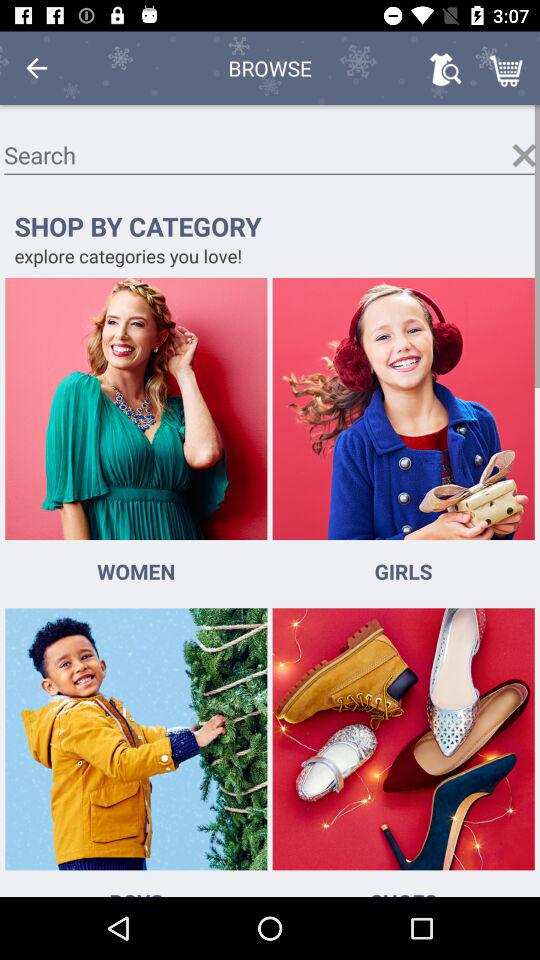How many shopping options are there on the page?
Answer the question using a single word or phrase. 4 